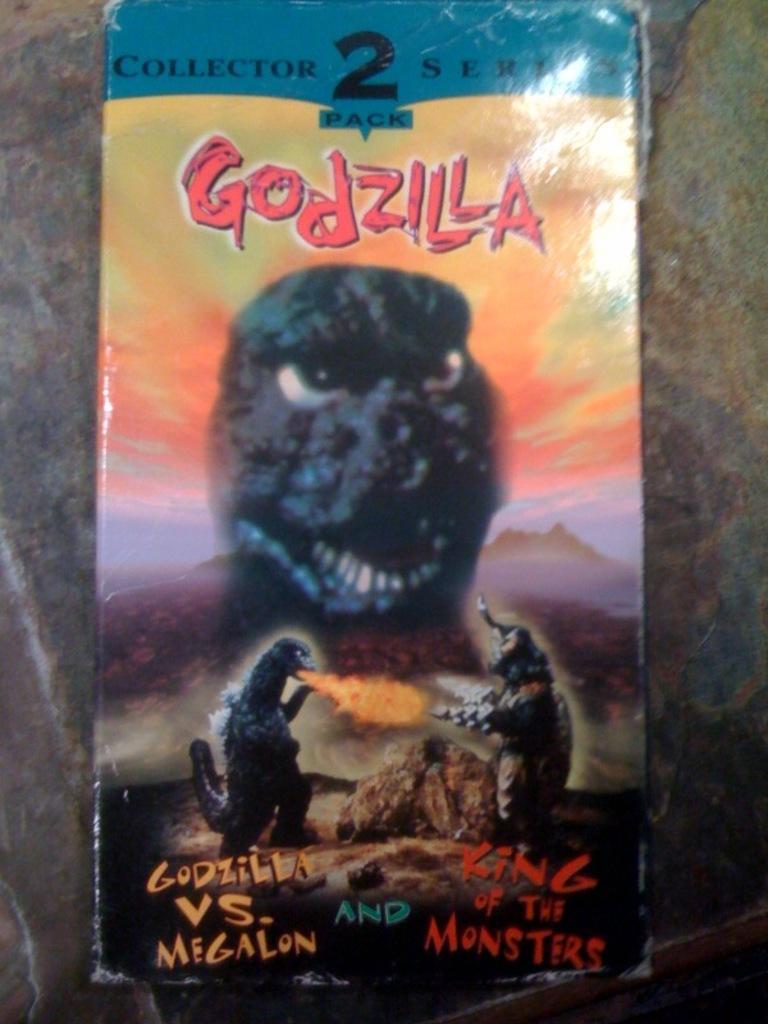Please provide a concise description of this image. In the center of the image there is a wall. On the wall, we can see one poster. On the poster, we can see dragons and some text. 